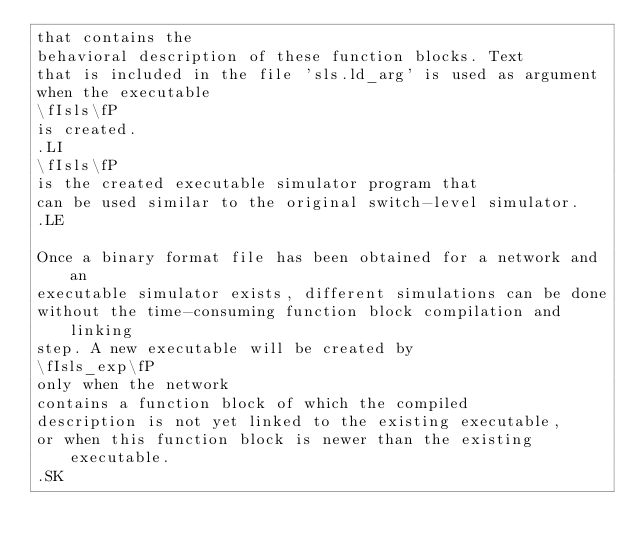Convert code to text. <code><loc_0><loc_0><loc_500><loc_500><_ObjectiveC_>that contains the
behavioral description of these function blocks. Text
that is included in the file 'sls.ld_arg' is used as argument
when the executable 
\fIsls\fP 
is created.
.LI
\fIsls\fP 
is the created executable simulator program that
can be used similar to the original switch-level simulator.
.LE

Once a binary format file has been obtained for a network and an
executable simulator exists, different simulations can be done
without the time-consuming function block compilation and linking
step. A new executable will be created by 
\fIsls_exp\fP 
only when the network
contains a function block of which the compiled
description is not yet linked to the existing executable,
or when this function block is newer than the existing executable.
.SK
</code> 